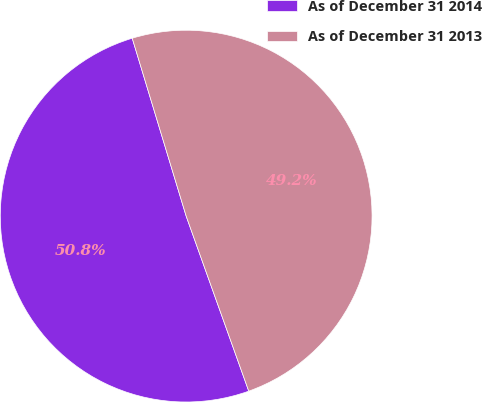<chart> <loc_0><loc_0><loc_500><loc_500><pie_chart><fcel>As of December 31 2014<fcel>As of December 31 2013<nl><fcel>50.78%<fcel>49.22%<nl></chart> 